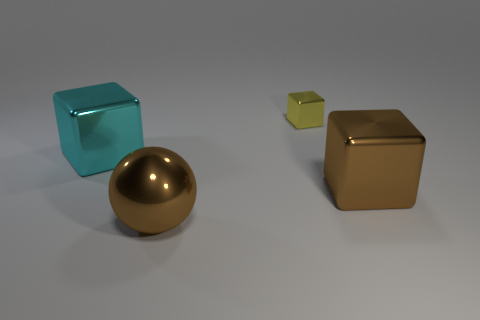Are there fewer large brown metallic cubes that are in front of the big ball than big cyan things? yes 